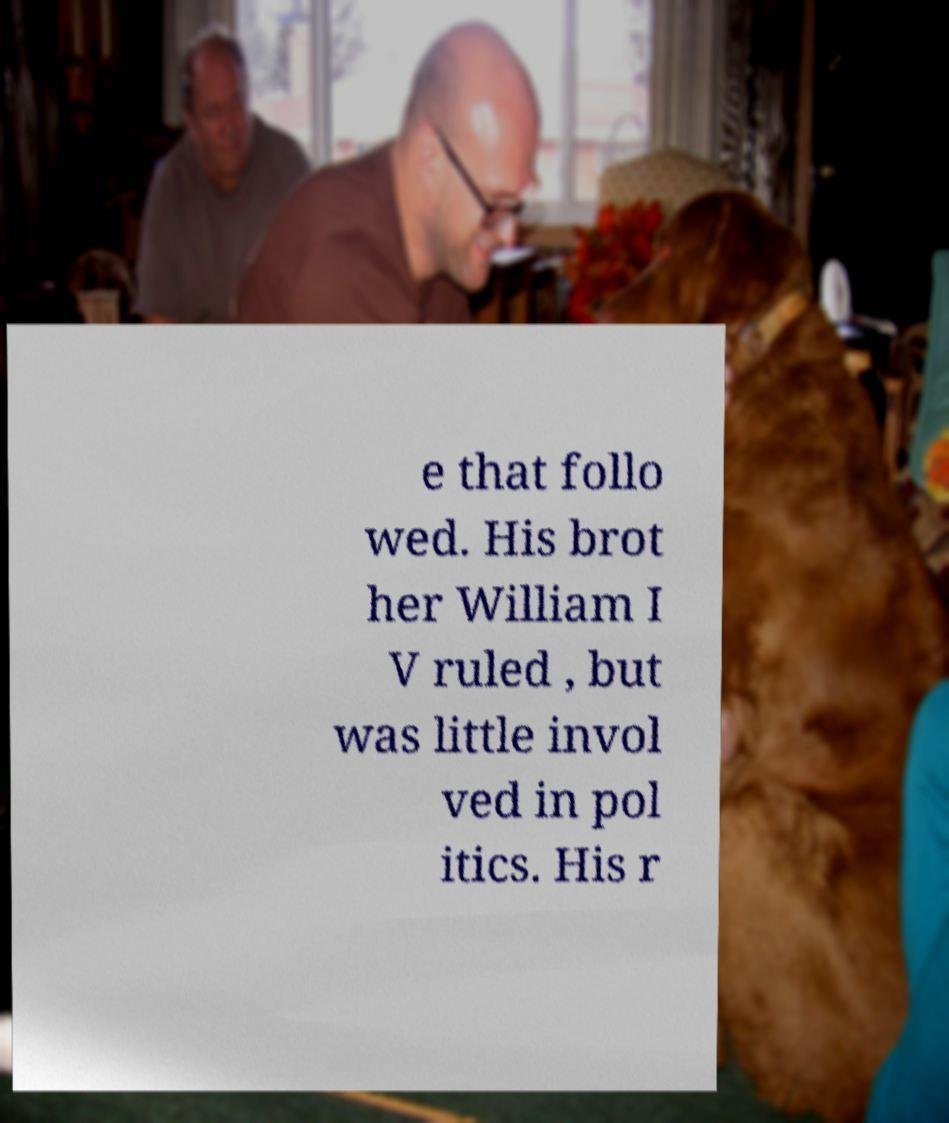Can you read and provide the text displayed in the image?This photo seems to have some interesting text. Can you extract and type it out for me? e that follo wed. His brot her William I V ruled , but was little invol ved in pol itics. His r 